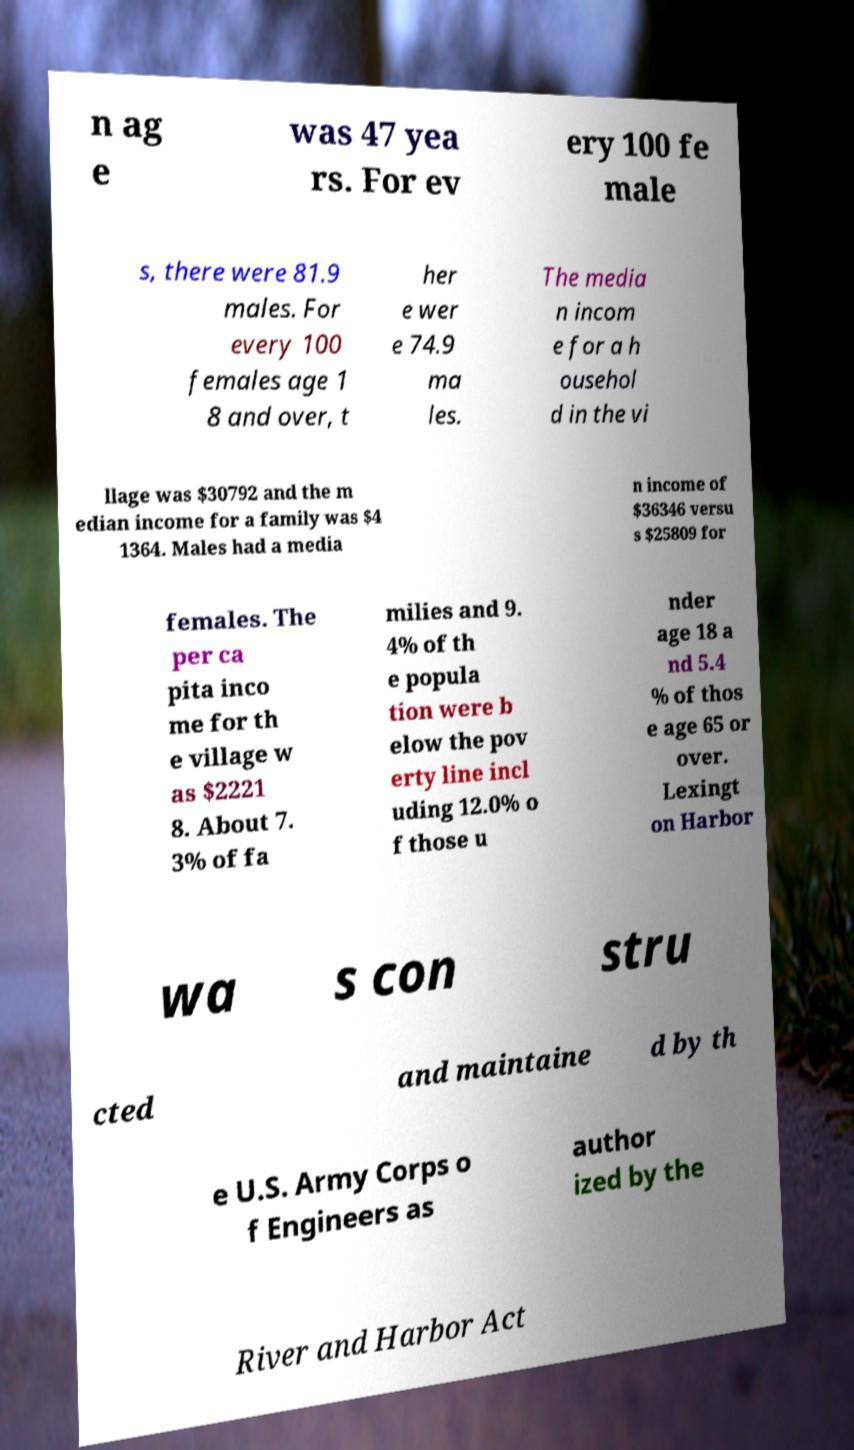Could you assist in decoding the text presented in this image and type it out clearly? n ag e was 47 yea rs. For ev ery 100 fe male s, there were 81.9 males. For every 100 females age 1 8 and over, t her e wer e 74.9 ma les. The media n incom e for a h ousehol d in the vi llage was $30792 and the m edian income for a family was $4 1364. Males had a media n income of $36346 versu s $25809 for females. The per ca pita inco me for th e village w as $2221 8. About 7. 3% of fa milies and 9. 4% of th e popula tion were b elow the pov erty line incl uding 12.0% o f those u nder age 18 a nd 5.4 % of thos e age 65 or over. Lexingt on Harbor wa s con stru cted and maintaine d by th e U.S. Army Corps o f Engineers as author ized by the River and Harbor Act 